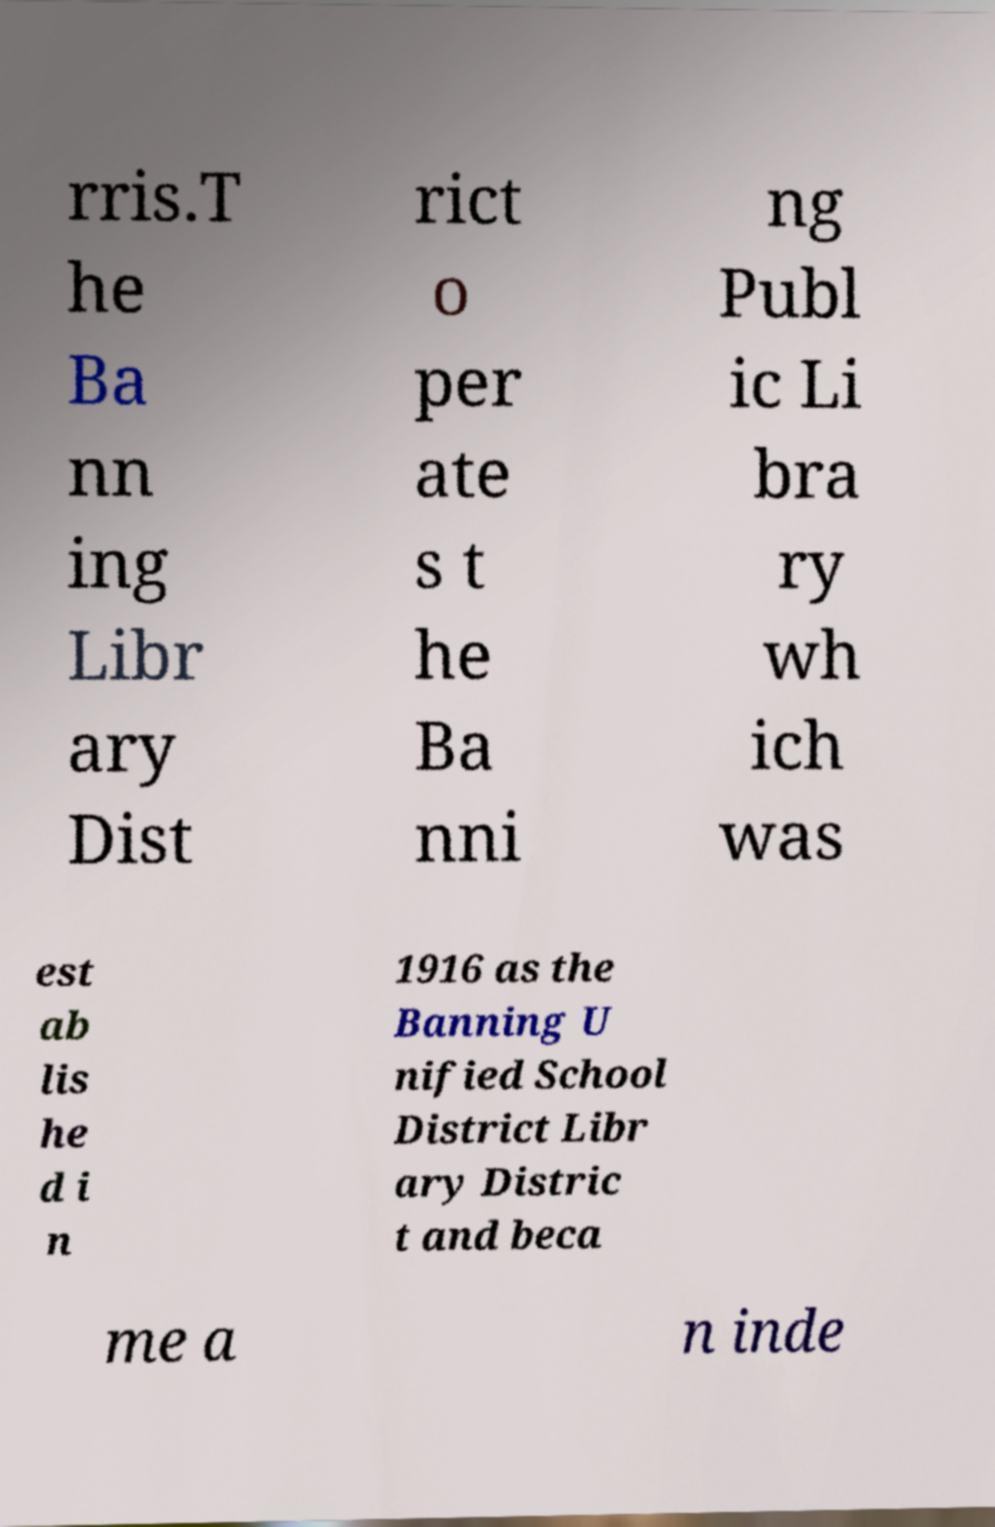There's text embedded in this image that I need extracted. Can you transcribe it verbatim? rris.T he Ba nn ing Libr ary Dist rict o per ate s t he Ba nni ng Publ ic Li bra ry wh ich was est ab lis he d i n 1916 as the Banning U nified School District Libr ary Distric t and beca me a n inde 